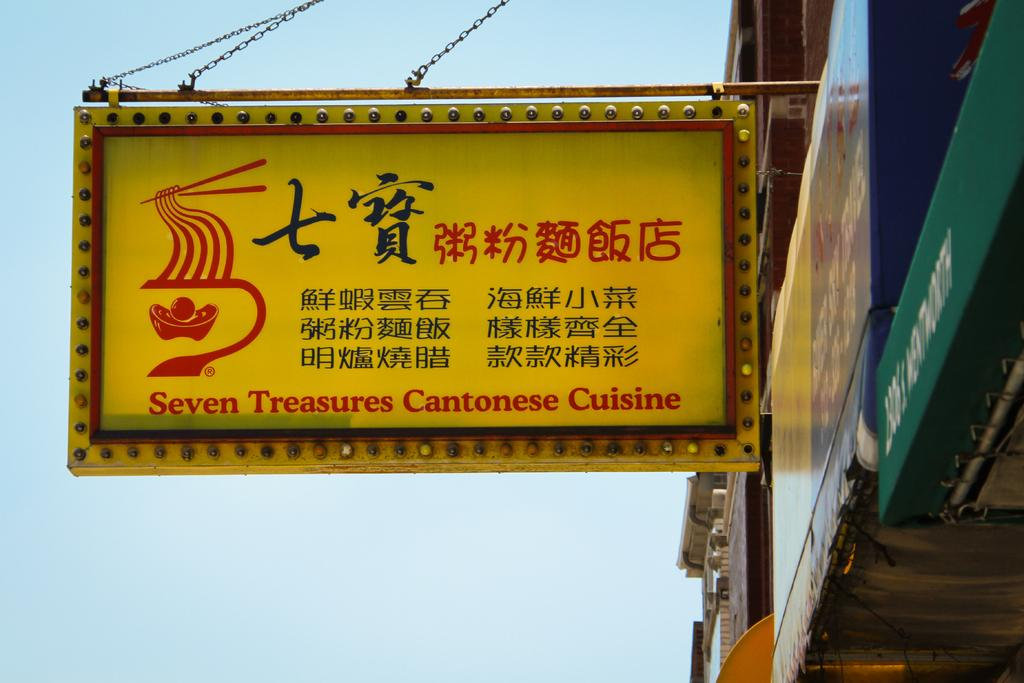Provide a one-sentence caption for the provided image. The signboard for Seven Treasures Cantonese Cuisine hanging from the building. 